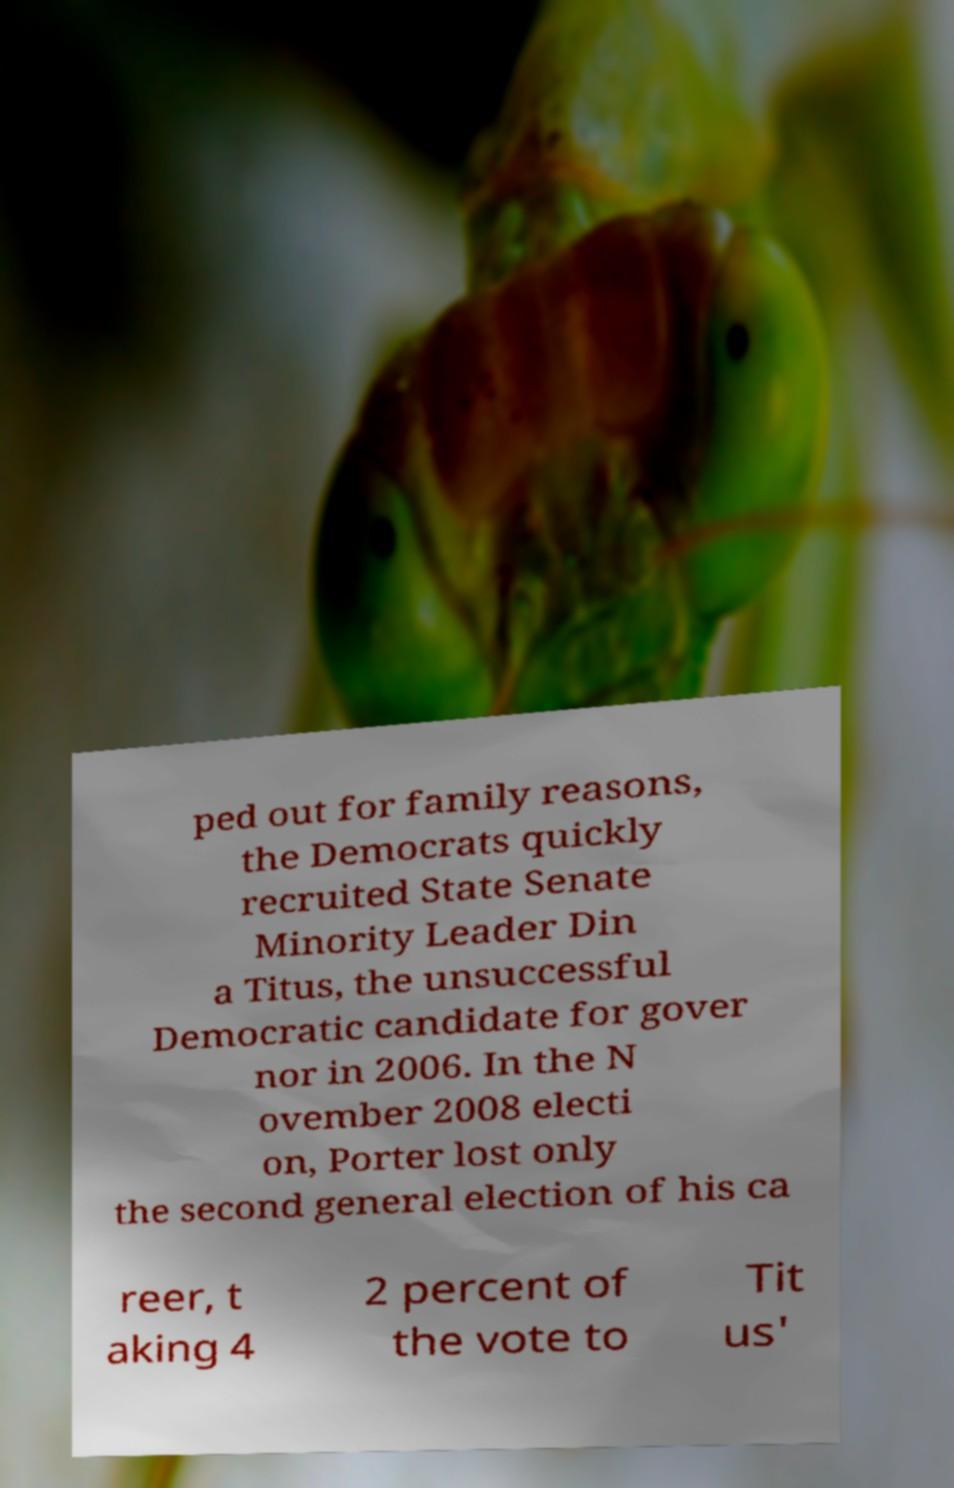Please identify and transcribe the text found in this image. ped out for family reasons, the Democrats quickly recruited State Senate Minority Leader Din a Titus, the unsuccessful Democratic candidate for gover nor in 2006. In the N ovember 2008 electi on, Porter lost only the second general election of his ca reer, t aking 4 2 percent of the vote to Tit us' 